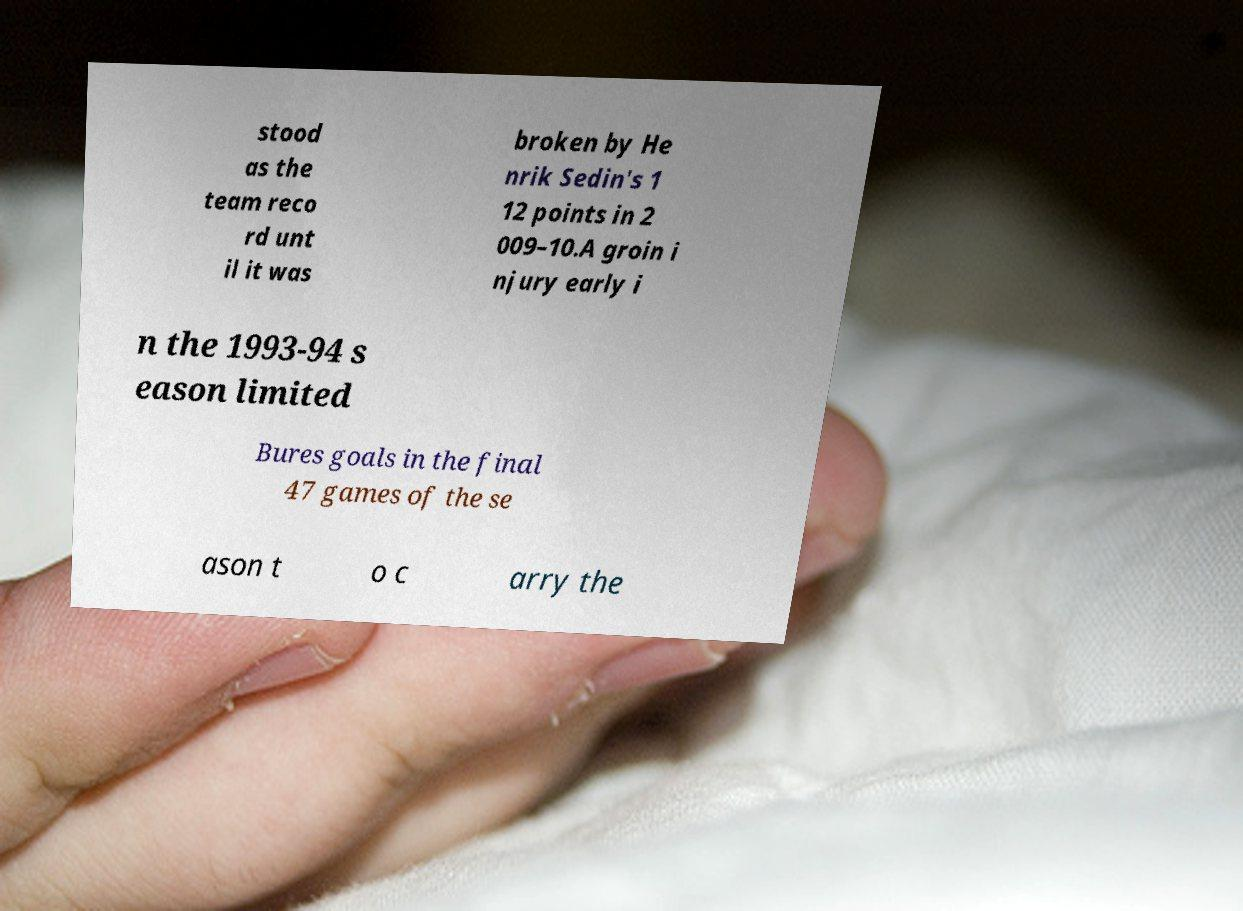Can you accurately transcribe the text from the provided image for me? stood as the team reco rd unt il it was broken by He nrik Sedin's 1 12 points in 2 009–10.A groin i njury early i n the 1993-94 s eason limited Bures goals in the final 47 games of the se ason t o c arry the 